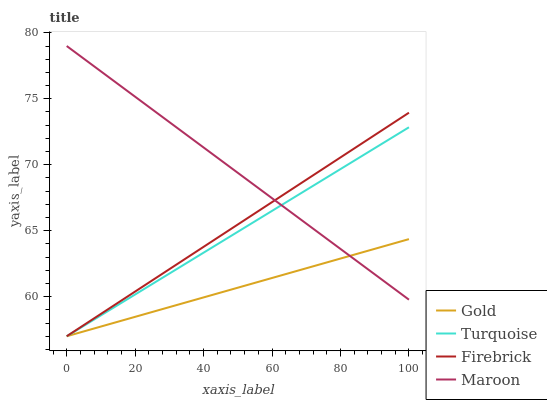Does Gold have the minimum area under the curve?
Answer yes or no. Yes. Does Maroon have the maximum area under the curve?
Answer yes or no. Yes. Does Turquoise have the minimum area under the curve?
Answer yes or no. No. Does Turquoise have the maximum area under the curve?
Answer yes or no. No. Is Turquoise the smoothest?
Answer yes or no. Yes. Is Maroon the roughest?
Answer yes or no. Yes. Is Gold the smoothest?
Answer yes or no. No. Is Gold the roughest?
Answer yes or no. No. Does Turquoise have the lowest value?
Answer yes or no. Yes. Does Maroon have the highest value?
Answer yes or no. Yes. Does Turquoise have the highest value?
Answer yes or no. No. Does Maroon intersect Gold?
Answer yes or no. Yes. Is Maroon less than Gold?
Answer yes or no. No. Is Maroon greater than Gold?
Answer yes or no. No. 